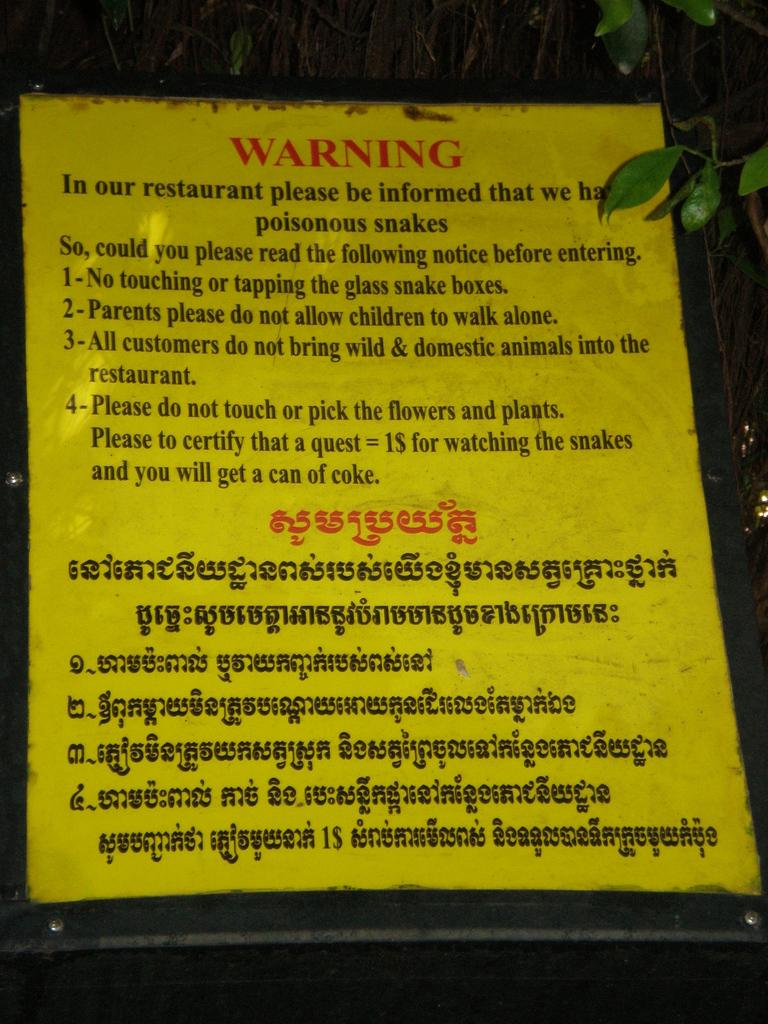What object is present in the image that is used for displaying information? There is a board in the image. What is the color of the board? The board is yellow in color. What can be seen on the board? There is text on the board. What colors are used for the text on the board? The text is red and black in color. What type of natural elements can be seen in the image? Leaves are visible in the image. Can you see a fork being used to cook something in the image? There is no fork visible in the image, nor is there any indication of cooking or food preparation. 